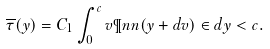<formula> <loc_0><loc_0><loc_500><loc_500>\overline { \tau } ( y ) = C _ { 1 } \int _ { 0 } ^ { c } v \P n n ( y + d v ) \in d { y < c } .</formula> 